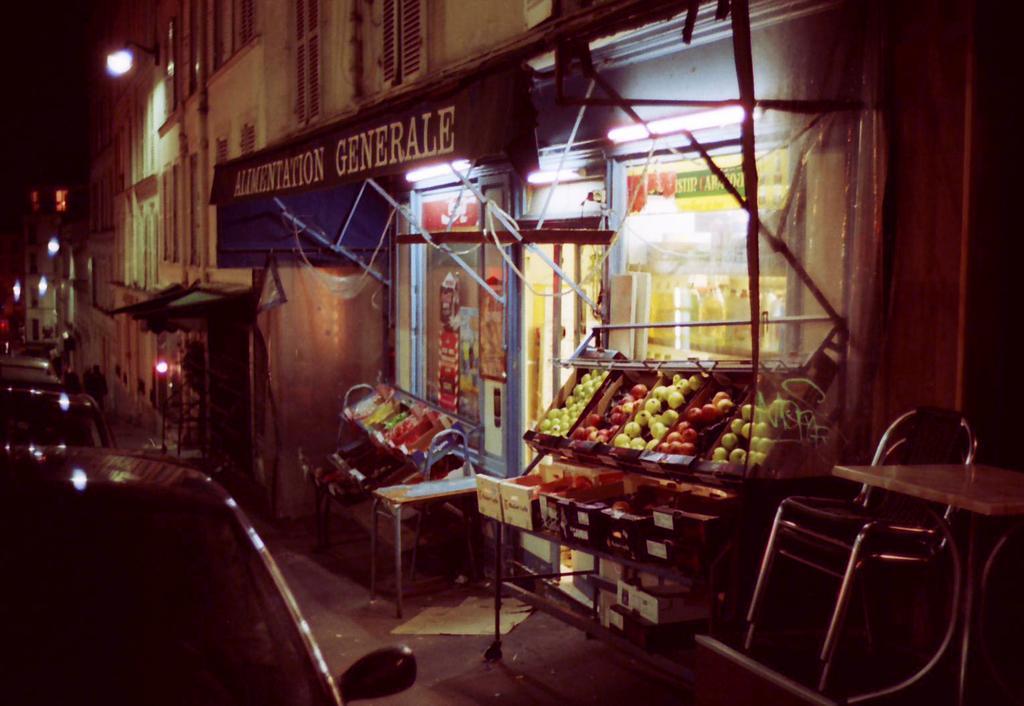In one or two sentences, can you explain what this image depicts? On the left corner of the picture, there are vehicles moving on the road. On the right corner of the picture, we see a shop and outside the shop, we see fruits placed in the wooden boxes. Beside that, there is a chair. There are buildings in the background and we even see street lights. This picture is clicked in the dark and this picture is clicked outside the city. 